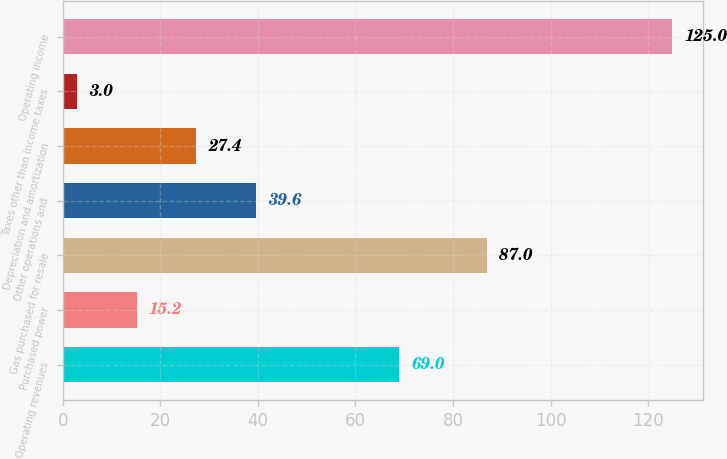Convert chart. <chart><loc_0><loc_0><loc_500><loc_500><bar_chart><fcel>Operating revenues<fcel>Purchased power<fcel>Gas purchased for resale<fcel>Other operations and<fcel>Depreciation and amortization<fcel>Taxes other than income taxes<fcel>Operating income<nl><fcel>69<fcel>15.2<fcel>87<fcel>39.6<fcel>27.4<fcel>3<fcel>125<nl></chart> 